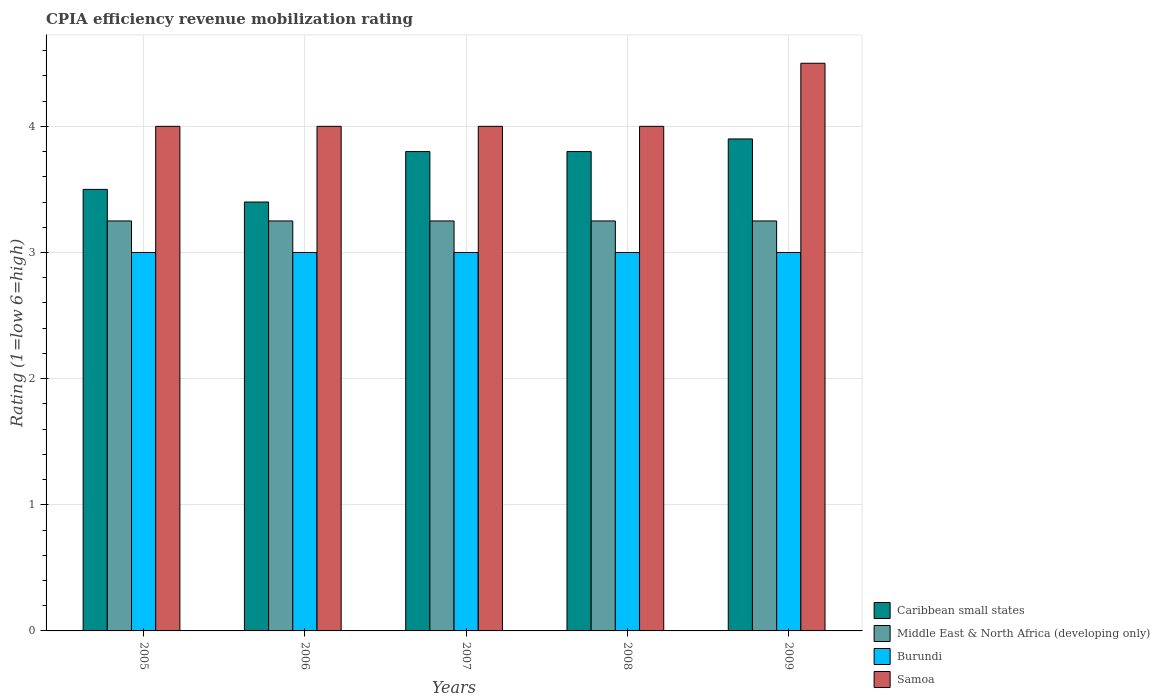How many different coloured bars are there?
Keep it short and to the point. 4. How many groups of bars are there?
Keep it short and to the point. 5. Are the number of bars on each tick of the X-axis equal?
Provide a succinct answer. Yes. How many bars are there on the 2nd tick from the left?
Your answer should be compact. 4. What is the label of the 5th group of bars from the left?
Provide a short and direct response. 2009. In how many cases, is the number of bars for a given year not equal to the number of legend labels?
Keep it short and to the point. 0. What is the CPIA rating in Caribbean small states in 2009?
Make the answer very short. 3.9. Across all years, what is the maximum CPIA rating in Samoa?
Give a very brief answer. 4.5. Across all years, what is the minimum CPIA rating in Caribbean small states?
Offer a terse response. 3.4. What is the total CPIA rating in Middle East & North Africa (developing only) in the graph?
Keep it short and to the point. 16.25. What is the difference between the CPIA rating in Burundi in 2005 and that in 2009?
Your response must be concise. 0. What is the difference between the CPIA rating in Middle East & North Africa (developing only) in 2008 and the CPIA rating in Burundi in 2006?
Your response must be concise. 0.25. In the year 2006, what is the difference between the CPIA rating in Caribbean small states and CPIA rating in Burundi?
Provide a succinct answer. 0.4. In how many years, is the CPIA rating in Samoa greater than 3.6?
Your response must be concise. 5. What is the ratio of the CPIA rating in Samoa in 2005 to that in 2009?
Ensure brevity in your answer.  0.89. Is the difference between the CPIA rating in Caribbean small states in 2006 and 2009 greater than the difference between the CPIA rating in Burundi in 2006 and 2009?
Your response must be concise. No. What is the difference between the highest and the second highest CPIA rating in Caribbean small states?
Your answer should be very brief. 0.1. What is the difference between the highest and the lowest CPIA rating in Caribbean small states?
Keep it short and to the point. 0.5. Is the sum of the CPIA rating in Middle East & North Africa (developing only) in 2008 and 2009 greater than the maximum CPIA rating in Caribbean small states across all years?
Provide a short and direct response. Yes. Is it the case that in every year, the sum of the CPIA rating in Samoa and CPIA rating in Caribbean small states is greater than the sum of CPIA rating in Middle East & North Africa (developing only) and CPIA rating in Burundi?
Your answer should be very brief. Yes. What does the 4th bar from the left in 2009 represents?
Offer a very short reply. Samoa. What does the 3rd bar from the right in 2006 represents?
Offer a very short reply. Middle East & North Africa (developing only). Is it the case that in every year, the sum of the CPIA rating in Samoa and CPIA rating in Burundi is greater than the CPIA rating in Middle East & North Africa (developing only)?
Give a very brief answer. Yes. How many bars are there?
Provide a short and direct response. 20. Are all the bars in the graph horizontal?
Provide a succinct answer. No. How many years are there in the graph?
Make the answer very short. 5. What is the difference between two consecutive major ticks on the Y-axis?
Provide a short and direct response. 1. How many legend labels are there?
Your answer should be compact. 4. How are the legend labels stacked?
Provide a short and direct response. Vertical. What is the title of the graph?
Provide a short and direct response. CPIA efficiency revenue mobilization rating. What is the label or title of the X-axis?
Keep it short and to the point. Years. What is the label or title of the Y-axis?
Offer a very short reply. Rating (1=low 6=high). What is the Rating (1=low 6=high) of Burundi in 2005?
Offer a terse response. 3. What is the Rating (1=low 6=high) of Samoa in 2006?
Offer a terse response. 4. What is the Rating (1=low 6=high) of Burundi in 2007?
Give a very brief answer. 3. What is the Rating (1=low 6=high) of Samoa in 2007?
Provide a succinct answer. 4. What is the Rating (1=low 6=high) of Caribbean small states in 2008?
Give a very brief answer. 3.8. What is the Rating (1=low 6=high) of Burundi in 2008?
Provide a succinct answer. 3. What is the Rating (1=low 6=high) in Samoa in 2008?
Provide a succinct answer. 4. What is the Rating (1=low 6=high) of Caribbean small states in 2009?
Provide a succinct answer. 3.9. What is the Rating (1=low 6=high) of Samoa in 2009?
Your answer should be compact. 4.5. Across all years, what is the maximum Rating (1=low 6=high) of Caribbean small states?
Offer a terse response. 3.9. Across all years, what is the maximum Rating (1=low 6=high) of Burundi?
Provide a short and direct response. 3. Across all years, what is the maximum Rating (1=low 6=high) in Samoa?
Ensure brevity in your answer.  4.5. What is the total Rating (1=low 6=high) of Middle East & North Africa (developing only) in the graph?
Ensure brevity in your answer.  16.25. What is the total Rating (1=low 6=high) in Burundi in the graph?
Provide a succinct answer. 15. What is the difference between the Rating (1=low 6=high) of Caribbean small states in 2005 and that in 2006?
Your answer should be compact. 0.1. What is the difference between the Rating (1=low 6=high) of Burundi in 2005 and that in 2006?
Ensure brevity in your answer.  0. What is the difference between the Rating (1=low 6=high) in Caribbean small states in 2005 and that in 2007?
Make the answer very short. -0.3. What is the difference between the Rating (1=low 6=high) in Middle East & North Africa (developing only) in 2005 and that in 2007?
Give a very brief answer. 0. What is the difference between the Rating (1=low 6=high) of Samoa in 2005 and that in 2007?
Your answer should be compact. 0. What is the difference between the Rating (1=low 6=high) of Caribbean small states in 2005 and that in 2008?
Make the answer very short. -0.3. What is the difference between the Rating (1=low 6=high) of Samoa in 2005 and that in 2008?
Offer a very short reply. 0. What is the difference between the Rating (1=low 6=high) of Caribbean small states in 2005 and that in 2009?
Provide a short and direct response. -0.4. What is the difference between the Rating (1=low 6=high) in Burundi in 2005 and that in 2009?
Your response must be concise. 0. What is the difference between the Rating (1=low 6=high) in Samoa in 2005 and that in 2009?
Offer a very short reply. -0.5. What is the difference between the Rating (1=low 6=high) of Caribbean small states in 2006 and that in 2007?
Your answer should be very brief. -0.4. What is the difference between the Rating (1=low 6=high) of Middle East & North Africa (developing only) in 2006 and that in 2007?
Make the answer very short. 0. What is the difference between the Rating (1=low 6=high) of Samoa in 2006 and that in 2008?
Provide a short and direct response. 0. What is the difference between the Rating (1=low 6=high) in Middle East & North Africa (developing only) in 2006 and that in 2009?
Your answer should be very brief. 0. What is the difference between the Rating (1=low 6=high) in Burundi in 2006 and that in 2009?
Ensure brevity in your answer.  0. What is the difference between the Rating (1=low 6=high) of Samoa in 2006 and that in 2009?
Offer a terse response. -0.5. What is the difference between the Rating (1=low 6=high) of Caribbean small states in 2007 and that in 2008?
Provide a short and direct response. 0. What is the difference between the Rating (1=low 6=high) of Middle East & North Africa (developing only) in 2007 and that in 2008?
Your response must be concise. 0. What is the difference between the Rating (1=low 6=high) of Burundi in 2007 and that in 2008?
Offer a terse response. 0. What is the difference between the Rating (1=low 6=high) of Caribbean small states in 2007 and that in 2009?
Your answer should be very brief. -0.1. What is the difference between the Rating (1=low 6=high) of Middle East & North Africa (developing only) in 2008 and that in 2009?
Make the answer very short. 0. What is the difference between the Rating (1=low 6=high) in Burundi in 2008 and that in 2009?
Provide a short and direct response. 0. What is the difference between the Rating (1=low 6=high) in Samoa in 2008 and that in 2009?
Offer a terse response. -0.5. What is the difference between the Rating (1=low 6=high) of Caribbean small states in 2005 and the Rating (1=low 6=high) of Middle East & North Africa (developing only) in 2006?
Provide a short and direct response. 0.25. What is the difference between the Rating (1=low 6=high) in Caribbean small states in 2005 and the Rating (1=low 6=high) in Burundi in 2006?
Offer a very short reply. 0.5. What is the difference between the Rating (1=low 6=high) in Caribbean small states in 2005 and the Rating (1=low 6=high) in Samoa in 2006?
Give a very brief answer. -0.5. What is the difference between the Rating (1=low 6=high) in Middle East & North Africa (developing only) in 2005 and the Rating (1=low 6=high) in Samoa in 2006?
Provide a succinct answer. -0.75. What is the difference between the Rating (1=low 6=high) of Burundi in 2005 and the Rating (1=low 6=high) of Samoa in 2006?
Provide a succinct answer. -1. What is the difference between the Rating (1=low 6=high) in Caribbean small states in 2005 and the Rating (1=low 6=high) in Middle East & North Africa (developing only) in 2007?
Keep it short and to the point. 0.25. What is the difference between the Rating (1=low 6=high) in Caribbean small states in 2005 and the Rating (1=low 6=high) in Samoa in 2007?
Give a very brief answer. -0.5. What is the difference between the Rating (1=low 6=high) of Middle East & North Africa (developing only) in 2005 and the Rating (1=low 6=high) of Samoa in 2007?
Keep it short and to the point. -0.75. What is the difference between the Rating (1=low 6=high) of Burundi in 2005 and the Rating (1=low 6=high) of Samoa in 2007?
Ensure brevity in your answer.  -1. What is the difference between the Rating (1=low 6=high) in Caribbean small states in 2005 and the Rating (1=low 6=high) in Samoa in 2008?
Give a very brief answer. -0.5. What is the difference between the Rating (1=low 6=high) of Middle East & North Africa (developing only) in 2005 and the Rating (1=low 6=high) of Samoa in 2008?
Make the answer very short. -0.75. What is the difference between the Rating (1=low 6=high) of Caribbean small states in 2005 and the Rating (1=low 6=high) of Burundi in 2009?
Offer a very short reply. 0.5. What is the difference between the Rating (1=low 6=high) of Caribbean small states in 2005 and the Rating (1=low 6=high) of Samoa in 2009?
Offer a terse response. -1. What is the difference between the Rating (1=low 6=high) in Middle East & North Africa (developing only) in 2005 and the Rating (1=low 6=high) in Samoa in 2009?
Provide a short and direct response. -1.25. What is the difference between the Rating (1=low 6=high) in Burundi in 2005 and the Rating (1=low 6=high) in Samoa in 2009?
Provide a succinct answer. -1.5. What is the difference between the Rating (1=low 6=high) of Caribbean small states in 2006 and the Rating (1=low 6=high) of Burundi in 2007?
Ensure brevity in your answer.  0.4. What is the difference between the Rating (1=low 6=high) in Middle East & North Africa (developing only) in 2006 and the Rating (1=low 6=high) in Burundi in 2007?
Offer a terse response. 0.25. What is the difference between the Rating (1=low 6=high) in Middle East & North Africa (developing only) in 2006 and the Rating (1=low 6=high) in Samoa in 2007?
Provide a succinct answer. -0.75. What is the difference between the Rating (1=low 6=high) in Burundi in 2006 and the Rating (1=low 6=high) in Samoa in 2007?
Provide a short and direct response. -1. What is the difference between the Rating (1=low 6=high) of Middle East & North Africa (developing only) in 2006 and the Rating (1=low 6=high) of Burundi in 2008?
Your answer should be very brief. 0.25. What is the difference between the Rating (1=low 6=high) in Middle East & North Africa (developing only) in 2006 and the Rating (1=low 6=high) in Samoa in 2008?
Give a very brief answer. -0.75. What is the difference between the Rating (1=low 6=high) in Burundi in 2006 and the Rating (1=low 6=high) in Samoa in 2008?
Make the answer very short. -1. What is the difference between the Rating (1=low 6=high) in Caribbean small states in 2006 and the Rating (1=low 6=high) in Burundi in 2009?
Offer a terse response. 0.4. What is the difference between the Rating (1=low 6=high) of Caribbean small states in 2006 and the Rating (1=low 6=high) of Samoa in 2009?
Your response must be concise. -1.1. What is the difference between the Rating (1=low 6=high) of Middle East & North Africa (developing only) in 2006 and the Rating (1=low 6=high) of Samoa in 2009?
Keep it short and to the point. -1.25. What is the difference between the Rating (1=low 6=high) in Caribbean small states in 2007 and the Rating (1=low 6=high) in Middle East & North Africa (developing only) in 2008?
Your answer should be compact. 0.55. What is the difference between the Rating (1=low 6=high) in Caribbean small states in 2007 and the Rating (1=low 6=high) in Burundi in 2008?
Provide a short and direct response. 0.8. What is the difference between the Rating (1=low 6=high) in Middle East & North Africa (developing only) in 2007 and the Rating (1=low 6=high) in Samoa in 2008?
Provide a succinct answer. -0.75. What is the difference between the Rating (1=low 6=high) in Caribbean small states in 2007 and the Rating (1=low 6=high) in Middle East & North Africa (developing only) in 2009?
Give a very brief answer. 0.55. What is the difference between the Rating (1=low 6=high) in Caribbean small states in 2007 and the Rating (1=low 6=high) in Burundi in 2009?
Provide a short and direct response. 0.8. What is the difference between the Rating (1=low 6=high) in Caribbean small states in 2007 and the Rating (1=low 6=high) in Samoa in 2009?
Provide a short and direct response. -0.7. What is the difference between the Rating (1=low 6=high) in Middle East & North Africa (developing only) in 2007 and the Rating (1=low 6=high) in Samoa in 2009?
Make the answer very short. -1.25. What is the difference between the Rating (1=low 6=high) of Caribbean small states in 2008 and the Rating (1=low 6=high) of Middle East & North Africa (developing only) in 2009?
Offer a very short reply. 0.55. What is the difference between the Rating (1=low 6=high) of Middle East & North Africa (developing only) in 2008 and the Rating (1=low 6=high) of Samoa in 2009?
Ensure brevity in your answer.  -1.25. What is the average Rating (1=low 6=high) of Caribbean small states per year?
Keep it short and to the point. 3.68. In the year 2005, what is the difference between the Rating (1=low 6=high) in Caribbean small states and Rating (1=low 6=high) in Middle East & North Africa (developing only)?
Your response must be concise. 0.25. In the year 2005, what is the difference between the Rating (1=low 6=high) of Middle East & North Africa (developing only) and Rating (1=low 6=high) of Samoa?
Make the answer very short. -0.75. In the year 2006, what is the difference between the Rating (1=low 6=high) in Caribbean small states and Rating (1=low 6=high) in Middle East & North Africa (developing only)?
Ensure brevity in your answer.  0.15. In the year 2006, what is the difference between the Rating (1=low 6=high) of Middle East & North Africa (developing only) and Rating (1=low 6=high) of Samoa?
Keep it short and to the point. -0.75. In the year 2007, what is the difference between the Rating (1=low 6=high) of Caribbean small states and Rating (1=low 6=high) of Middle East & North Africa (developing only)?
Your answer should be very brief. 0.55. In the year 2007, what is the difference between the Rating (1=low 6=high) of Caribbean small states and Rating (1=low 6=high) of Samoa?
Keep it short and to the point. -0.2. In the year 2007, what is the difference between the Rating (1=low 6=high) of Middle East & North Africa (developing only) and Rating (1=low 6=high) of Samoa?
Your answer should be compact. -0.75. In the year 2008, what is the difference between the Rating (1=low 6=high) of Caribbean small states and Rating (1=low 6=high) of Middle East & North Africa (developing only)?
Offer a very short reply. 0.55. In the year 2008, what is the difference between the Rating (1=low 6=high) of Middle East & North Africa (developing only) and Rating (1=low 6=high) of Burundi?
Keep it short and to the point. 0.25. In the year 2008, what is the difference between the Rating (1=low 6=high) in Middle East & North Africa (developing only) and Rating (1=low 6=high) in Samoa?
Offer a very short reply. -0.75. In the year 2008, what is the difference between the Rating (1=low 6=high) of Burundi and Rating (1=low 6=high) of Samoa?
Offer a very short reply. -1. In the year 2009, what is the difference between the Rating (1=low 6=high) in Caribbean small states and Rating (1=low 6=high) in Middle East & North Africa (developing only)?
Offer a very short reply. 0.65. In the year 2009, what is the difference between the Rating (1=low 6=high) in Middle East & North Africa (developing only) and Rating (1=low 6=high) in Samoa?
Your response must be concise. -1.25. In the year 2009, what is the difference between the Rating (1=low 6=high) of Burundi and Rating (1=low 6=high) of Samoa?
Offer a very short reply. -1.5. What is the ratio of the Rating (1=low 6=high) in Caribbean small states in 2005 to that in 2006?
Your answer should be very brief. 1.03. What is the ratio of the Rating (1=low 6=high) in Middle East & North Africa (developing only) in 2005 to that in 2006?
Offer a terse response. 1. What is the ratio of the Rating (1=low 6=high) of Samoa in 2005 to that in 2006?
Offer a very short reply. 1. What is the ratio of the Rating (1=low 6=high) in Caribbean small states in 2005 to that in 2007?
Offer a terse response. 0.92. What is the ratio of the Rating (1=low 6=high) in Burundi in 2005 to that in 2007?
Make the answer very short. 1. What is the ratio of the Rating (1=low 6=high) of Samoa in 2005 to that in 2007?
Make the answer very short. 1. What is the ratio of the Rating (1=low 6=high) of Caribbean small states in 2005 to that in 2008?
Keep it short and to the point. 0.92. What is the ratio of the Rating (1=low 6=high) of Middle East & North Africa (developing only) in 2005 to that in 2008?
Make the answer very short. 1. What is the ratio of the Rating (1=low 6=high) in Samoa in 2005 to that in 2008?
Give a very brief answer. 1. What is the ratio of the Rating (1=low 6=high) of Caribbean small states in 2005 to that in 2009?
Make the answer very short. 0.9. What is the ratio of the Rating (1=low 6=high) of Middle East & North Africa (developing only) in 2005 to that in 2009?
Provide a succinct answer. 1. What is the ratio of the Rating (1=low 6=high) of Burundi in 2005 to that in 2009?
Offer a terse response. 1. What is the ratio of the Rating (1=low 6=high) of Caribbean small states in 2006 to that in 2007?
Your answer should be very brief. 0.89. What is the ratio of the Rating (1=low 6=high) in Burundi in 2006 to that in 2007?
Give a very brief answer. 1. What is the ratio of the Rating (1=low 6=high) of Caribbean small states in 2006 to that in 2008?
Provide a succinct answer. 0.89. What is the ratio of the Rating (1=low 6=high) of Burundi in 2006 to that in 2008?
Provide a succinct answer. 1. What is the ratio of the Rating (1=low 6=high) of Samoa in 2006 to that in 2008?
Ensure brevity in your answer.  1. What is the ratio of the Rating (1=low 6=high) in Caribbean small states in 2006 to that in 2009?
Keep it short and to the point. 0.87. What is the ratio of the Rating (1=low 6=high) in Middle East & North Africa (developing only) in 2006 to that in 2009?
Provide a short and direct response. 1. What is the ratio of the Rating (1=low 6=high) in Burundi in 2006 to that in 2009?
Offer a very short reply. 1. What is the ratio of the Rating (1=low 6=high) of Samoa in 2006 to that in 2009?
Your response must be concise. 0.89. What is the ratio of the Rating (1=low 6=high) in Caribbean small states in 2007 to that in 2008?
Offer a terse response. 1. What is the ratio of the Rating (1=low 6=high) in Burundi in 2007 to that in 2008?
Provide a succinct answer. 1. What is the ratio of the Rating (1=low 6=high) in Samoa in 2007 to that in 2008?
Keep it short and to the point. 1. What is the ratio of the Rating (1=low 6=high) of Caribbean small states in 2007 to that in 2009?
Offer a very short reply. 0.97. What is the ratio of the Rating (1=low 6=high) of Burundi in 2007 to that in 2009?
Offer a terse response. 1. What is the ratio of the Rating (1=low 6=high) of Samoa in 2007 to that in 2009?
Your answer should be very brief. 0.89. What is the ratio of the Rating (1=low 6=high) in Caribbean small states in 2008 to that in 2009?
Make the answer very short. 0.97. What is the ratio of the Rating (1=low 6=high) of Burundi in 2008 to that in 2009?
Your response must be concise. 1. What is the difference between the highest and the second highest Rating (1=low 6=high) of Caribbean small states?
Provide a short and direct response. 0.1. What is the difference between the highest and the second highest Rating (1=low 6=high) of Middle East & North Africa (developing only)?
Offer a terse response. 0. What is the difference between the highest and the lowest Rating (1=low 6=high) of Burundi?
Ensure brevity in your answer.  0. What is the difference between the highest and the lowest Rating (1=low 6=high) of Samoa?
Your answer should be very brief. 0.5. 